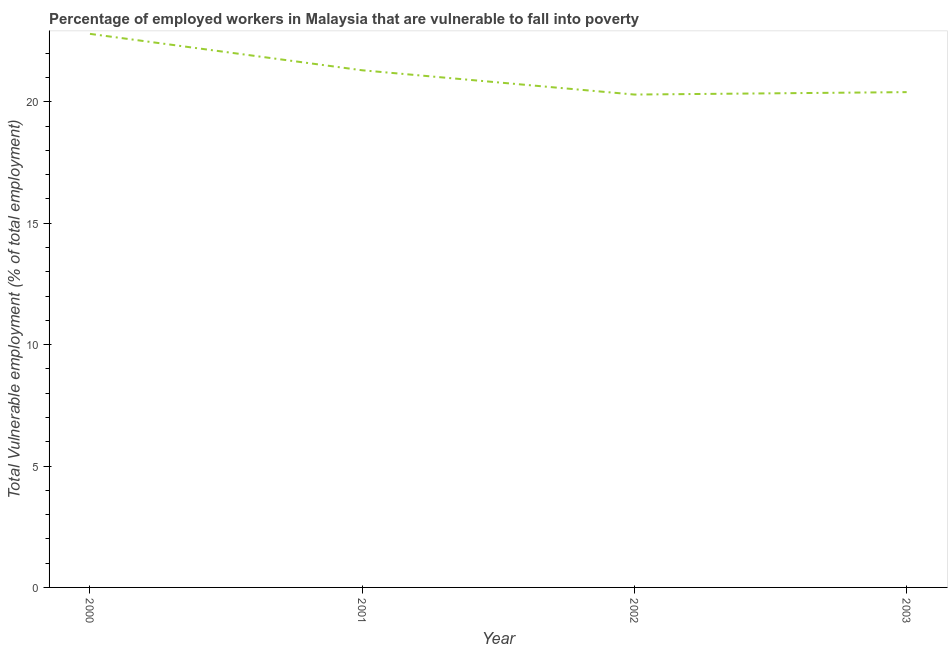What is the total vulnerable employment in 2003?
Your response must be concise. 20.4. Across all years, what is the maximum total vulnerable employment?
Offer a terse response. 22.8. Across all years, what is the minimum total vulnerable employment?
Make the answer very short. 20.3. What is the sum of the total vulnerable employment?
Make the answer very short. 84.8. What is the difference between the total vulnerable employment in 2002 and 2003?
Give a very brief answer. -0.1. What is the average total vulnerable employment per year?
Give a very brief answer. 21.2. What is the median total vulnerable employment?
Ensure brevity in your answer.  20.85. In how many years, is the total vulnerable employment greater than 9 %?
Keep it short and to the point. 4. Do a majority of the years between 2000 and 2002 (inclusive) have total vulnerable employment greater than 15 %?
Make the answer very short. Yes. What is the ratio of the total vulnerable employment in 2001 to that in 2002?
Your answer should be very brief. 1.05. What is the difference between the highest and the lowest total vulnerable employment?
Offer a very short reply. 2.5. In how many years, is the total vulnerable employment greater than the average total vulnerable employment taken over all years?
Your response must be concise. 2. Does the total vulnerable employment monotonically increase over the years?
Make the answer very short. No. What is the difference between two consecutive major ticks on the Y-axis?
Ensure brevity in your answer.  5. Are the values on the major ticks of Y-axis written in scientific E-notation?
Your answer should be very brief. No. Does the graph contain any zero values?
Your response must be concise. No. Does the graph contain grids?
Offer a terse response. No. What is the title of the graph?
Offer a very short reply. Percentage of employed workers in Malaysia that are vulnerable to fall into poverty. What is the label or title of the X-axis?
Make the answer very short. Year. What is the label or title of the Y-axis?
Provide a short and direct response. Total Vulnerable employment (% of total employment). What is the Total Vulnerable employment (% of total employment) in 2000?
Your answer should be compact. 22.8. What is the Total Vulnerable employment (% of total employment) in 2001?
Provide a succinct answer. 21.3. What is the Total Vulnerable employment (% of total employment) of 2002?
Give a very brief answer. 20.3. What is the Total Vulnerable employment (% of total employment) in 2003?
Ensure brevity in your answer.  20.4. What is the difference between the Total Vulnerable employment (% of total employment) in 2000 and 2002?
Give a very brief answer. 2.5. What is the difference between the Total Vulnerable employment (% of total employment) in 2001 and 2002?
Your answer should be compact. 1. What is the difference between the Total Vulnerable employment (% of total employment) in 2001 and 2003?
Provide a short and direct response. 0.9. What is the difference between the Total Vulnerable employment (% of total employment) in 2002 and 2003?
Keep it short and to the point. -0.1. What is the ratio of the Total Vulnerable employment (% of total employment) in 2000 to that in 2001?
Keep it short and to the point. 1.07. What is the ratio of the Total Vulnerable employment (% of total employment) in 2000 to that in 2002?
Make the answer very short. 1.12. What is the ratio of the Total Vulnerable employment (% of total employment) in 2000 to that in 2003?
Give a very brief answer. 1.12. What is the ratio of the Total Vulnerable employment (% of total employment) in 2001 to that in 2002?
Ensure brevity in your answer.  1.05. What is the ratio of the Total Vulnerable employment (% of total employment) in 2001 to that in 2003?
Provide a succinct answer. 1.04. 